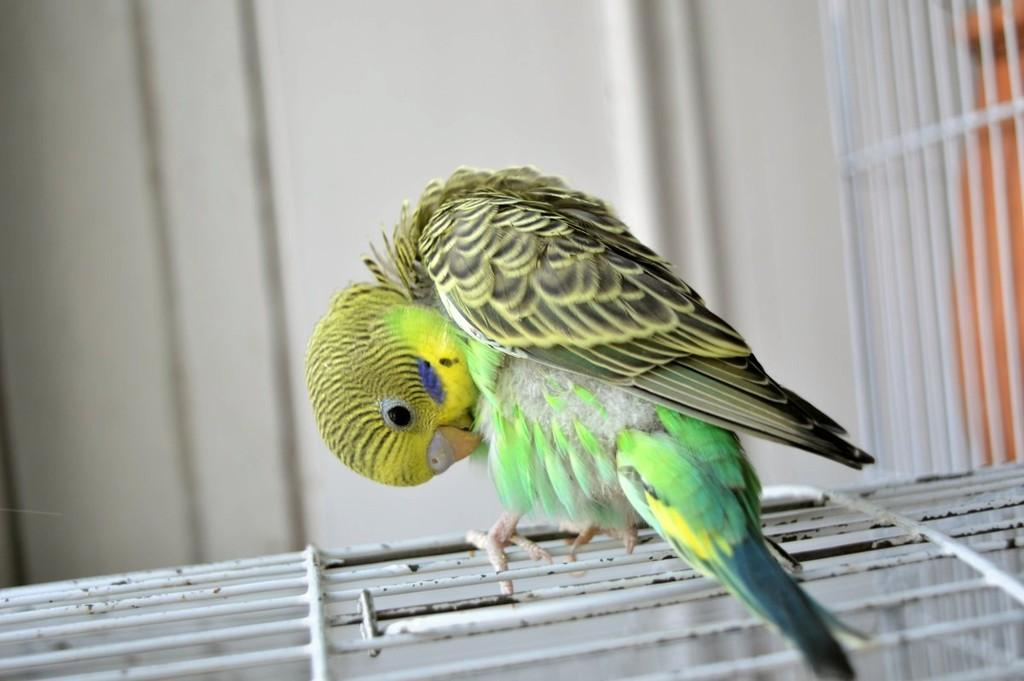What type of animal is in the image? There is a parrot in the image. Where is the parrot located? The parrot is standing on a cage. What can be seen in the background of the image? There is a wall in the background of the image. What color is the wall? The wall is white in color. What type of apparel are the boys and girl wearing in the image? There are no boys or girl present in the image; it only features a parrot standing on a cage. 